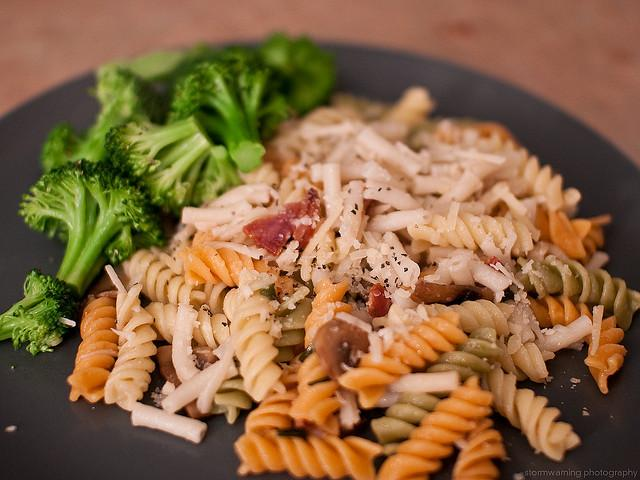What is next to the pasta? Please explain your reasoning. broccoli. The food is green and looks like a bunch of little "trees.". 